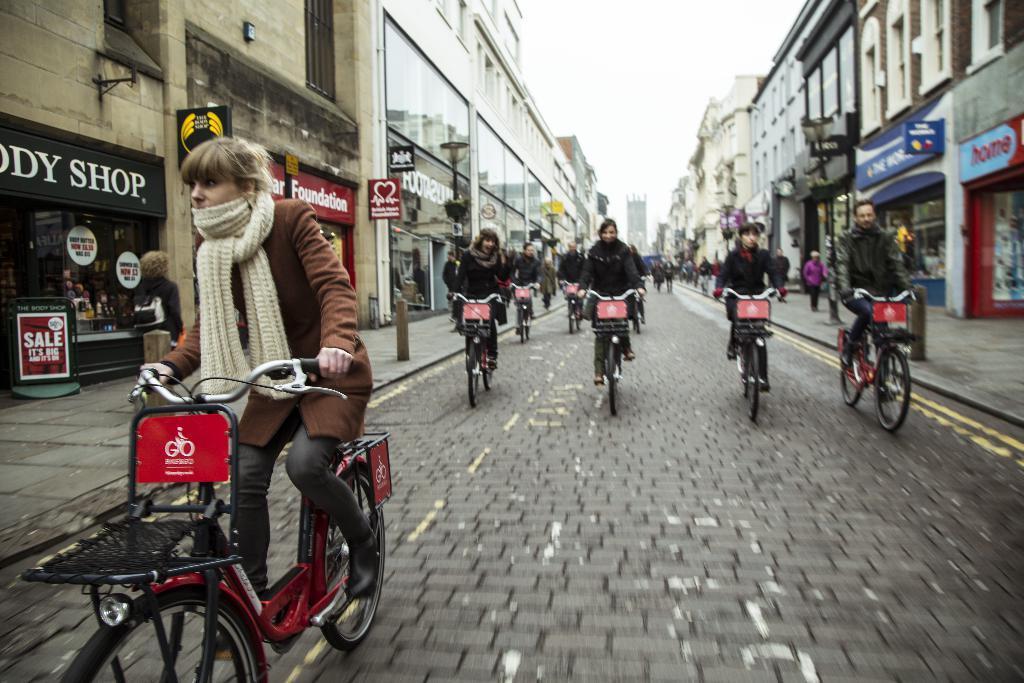Please provide a concise description of this image. In this image I can see few people are cycling their cycles. In the background I can see few more people and number of buildings. 